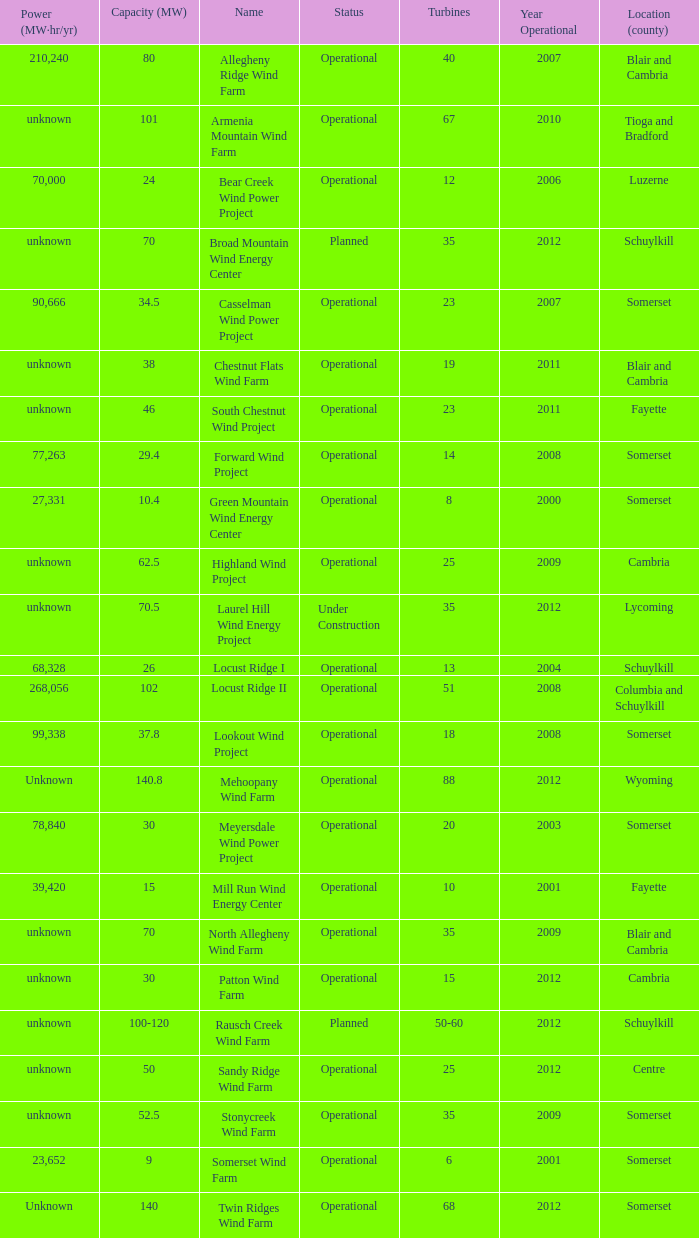What all capacities have turbines between 50-60? 100-120. 